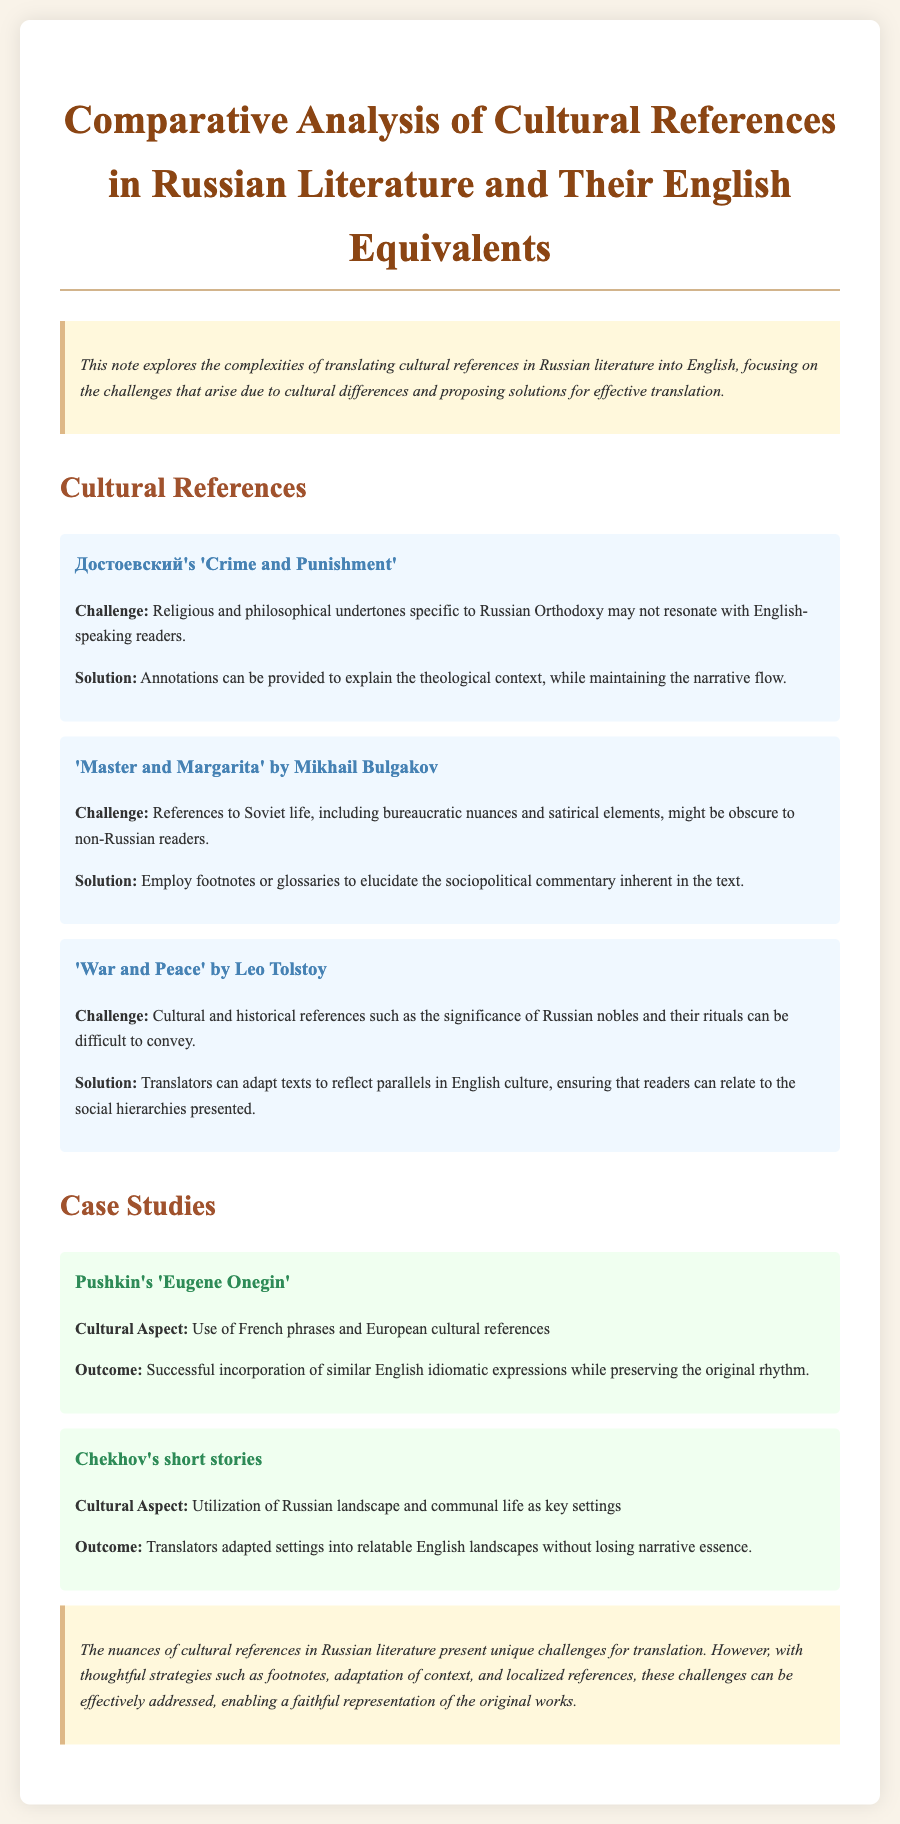What is the title of the document? The title is found at the beginning of the rendered document, summarizing the main focus on cultural references in literature.
Answer: Comparative Analysis of Cultural References in Russian Literature and Their English Equivalents Who is the author of 'Crime and Punishment'? The document mentions Dostoevsky as the author of 'Crime and Punishment'.
Answer: Достоевский What cultural references are highlighted in 'Master and Margarita'? The document specifies that 'Master and Margarita' includes references to Soviet life and bureaucratic nuances.
Answer: Soviet life, bureaucratic nuances What is the proposed solution for translating religious elements in 'Crime and Punishment'? The document suggests that annotations can be provided to clarify the theological context for the readers.
Answer: Annotations How does the translation of Pushkin's 'Eugene Onegin' handle cultural expressions? The case study mentions successful incorporation of similar English idiomatic expressions while preserving the original rhythm.
Answer: English idiomatic expressions What is one challenge of translating 'War and Peace'? The document outlines that conveying the significance of Russian nobles and their rituals poses a challenge for translators.
Answer: Russian nobles, rituals What adaptations are suggested for Chekhov’s short stories? The document describes that settings were adapted into relatable English landscapes while maintaining narrative essence.
Answer: Relatable English landscapes How do footnotes help in translation according to the document? The document states that footnotes can elucidate sociopolitical commentary for non-Russian readers.
Answer: Elucidate sociopolitical commentary 